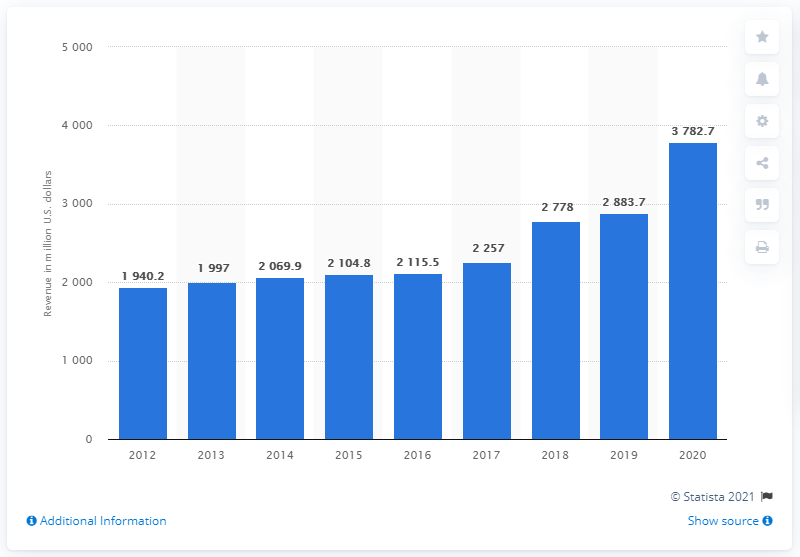Identify some key points in this picture. In 2020, the revenue of PerkinElmer was $37,827. 